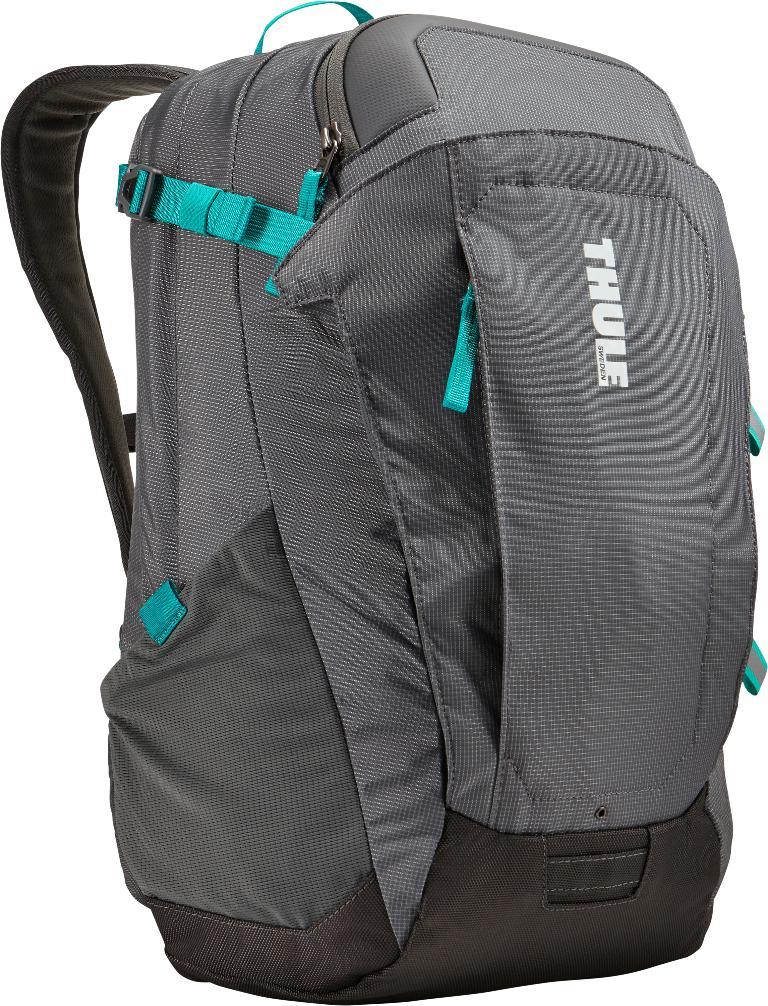Who makes this backpack?
Offer a very short reply. Thule. 